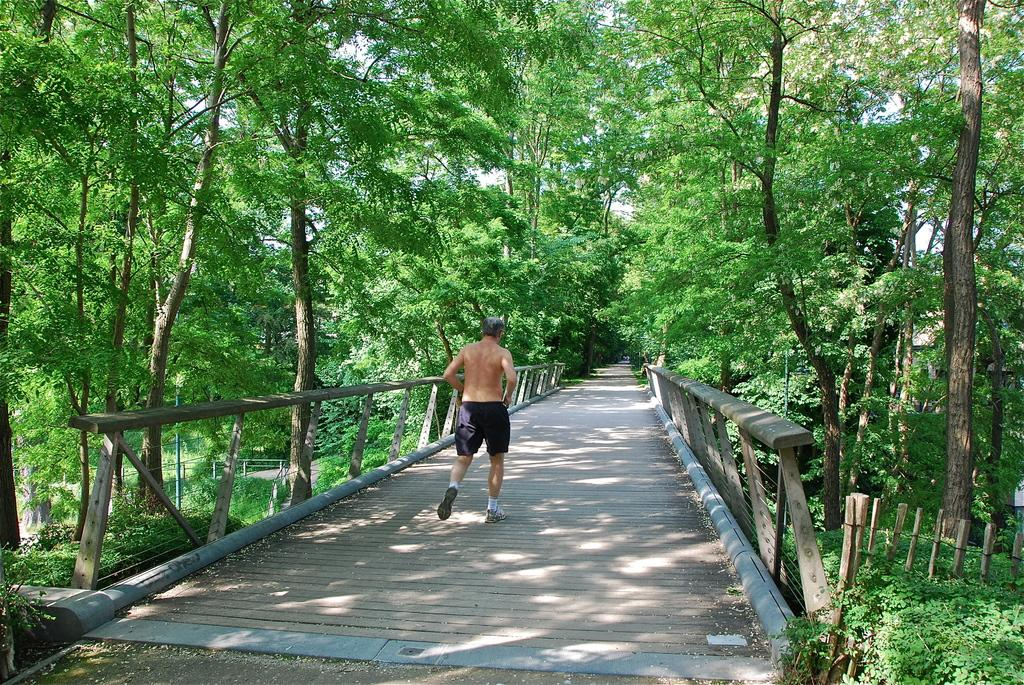Who is the main subject in the image? There is a man in the image. What is the man doing in the image? The man is running in the image. Where is the man running in the image? The man is running on a bridge in the image. What type of vegetation can be seen in the image? There are green color trees in the image. What type of spoon is the man holding in the image? There is no spoon present in the image; the man is running on a bridge. What is the relation between the man and the trees in the image? The provided facts do not mention any relation between the man and the trees; they are simply two separate elements in the image. 